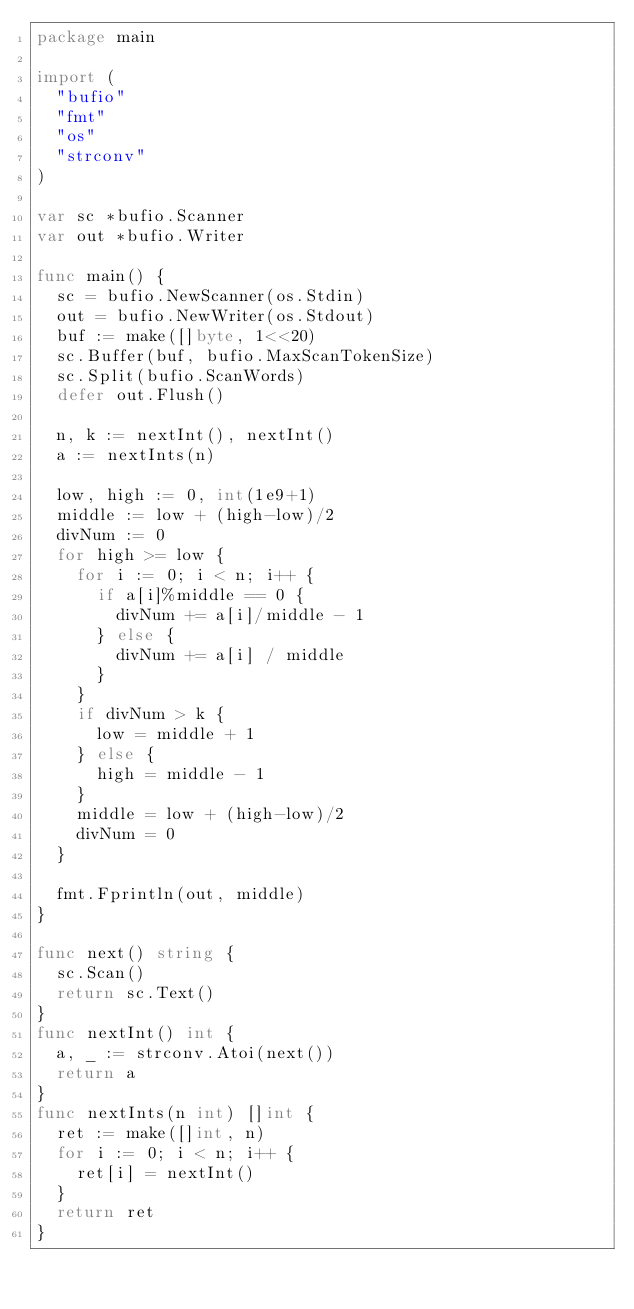<code> <loc_0><loc_0><loc_500><loc_500><_Go_>package main

import (
	"bufio"
	"fmt"
	"os"
	"strconv"
)

var sc *bufio.Scanner
var out *bufio.Writer

func main() {
	sc = bufio.NewScanner(os.Stdin)
	out = bufio.NewWriter(os.Stdout)
	buf := make([]byte, 1<<20)
	sc.Buffer(buf, bufio.MaxScanTokenSize)
	sc.Split(bufio.ScanWords)
	defer out.Flush()

	n, k := nextInt(), nextInt()
	a := nextInts(n)

	low, high := 0, int(1e9+1)
	middle := low + (high-low)/2
	divNum := 0
	for high >= low {
		for i := 0; i < n; i++ {
			if a[i]%middle == 0 {
				divNum += a[i]/middle - 1
			} else {
				divNum += a[i] / middle
			}
		}
		if divNum > k {
			low = middle + 1
		} else {
			high = middle - 1
		}
		middle = low + (high-low)/2
		divNum = 0
	}

	fmt.Fprintln(out, middle)
}

func next() string {
	sc.Scan()
	return sc.Text()
}
func nextInt() int {
	a, _ := strconv.Atoi(next())
	return a
}
func nextInts(n int) []int {
	ret := make([]int, n)
	for i := 0; i < n; i++ {
		ret[i] = nextInt()
	}
	return ret
}
</code> 